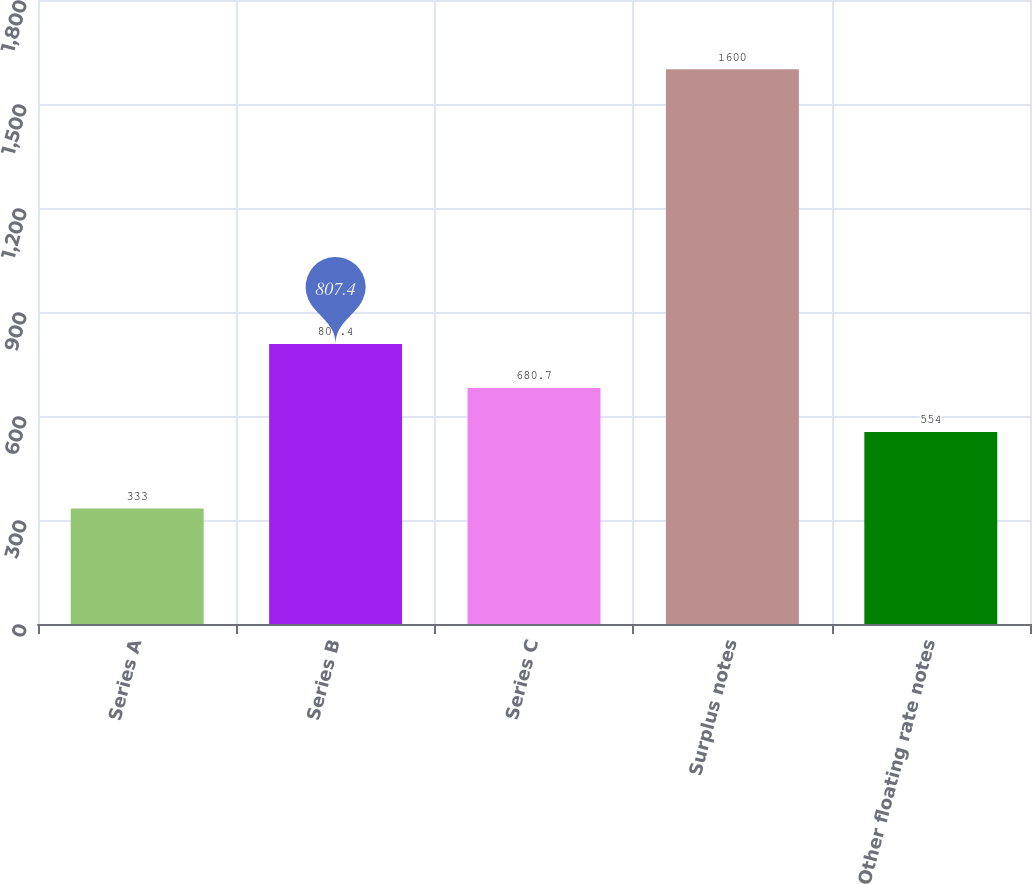Convert chart. <chart><loc_0><loc_0><loc_500><loc_500><bar_chart><fcel>Series A<fcel>Series B<fcel>Series C<fcel>Surplus notes<fcel>Other floating rate notes<nl><fcel>333<fcel>807.4<fcel>680.7<fcel>1600<fcel>554<nl></chart> 